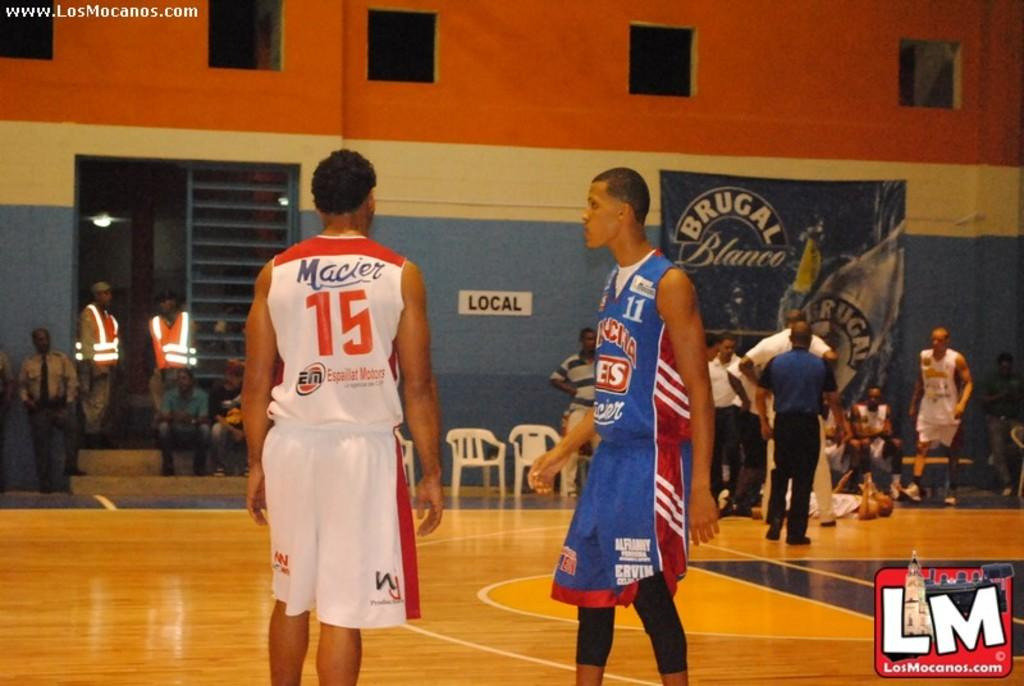<image>
Summarize the visual content of the image. Basket ball players on opposing teams wearing numbers 15 and 11 stand in the middle of the court. 